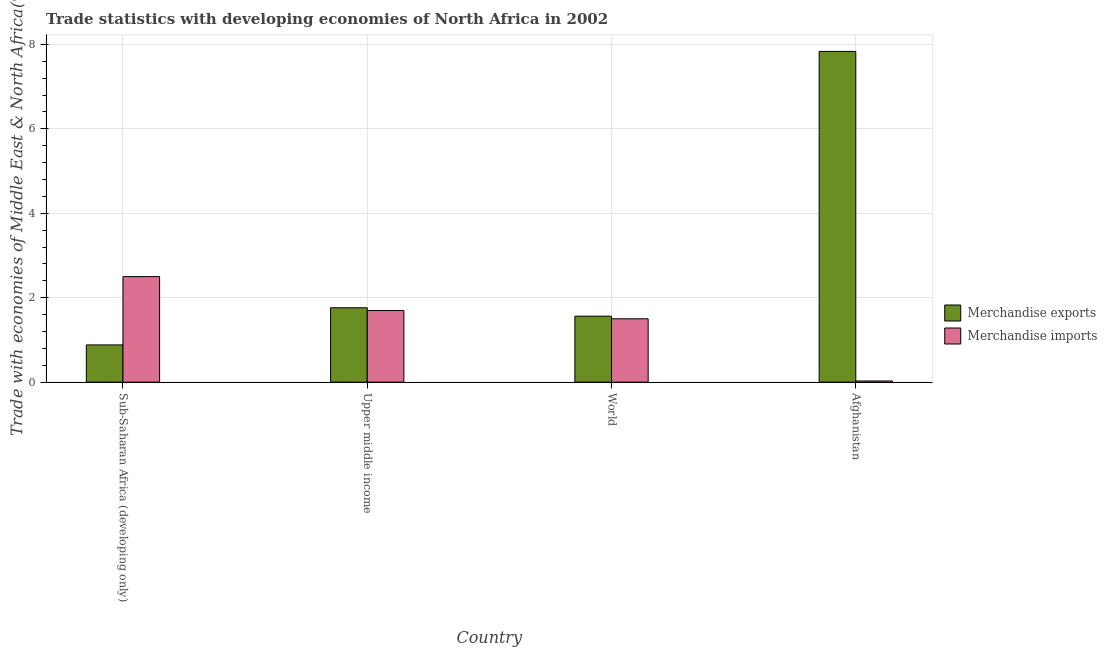How many bars are there on the 4th tick from the left?
Provide a succinct answer. 2. What is the label of the 4th group of bars from the left?
Offer a terse response. Afghanistan. What is the merchandise exports in Upper middle income?
Your response must be concise. 1.76. Across all countries, what is the maximum merchandise imports?
Offer a very short reply. 2.5. Across all countries, what is the minimum merchandise imports?
Ensure brevity in your answer.  0.03. In which country was the merchandise imports maximum?
Give a very brief answer. Sub-Saharan Africa (developing only). In which country was the merchandise imports minimum?
Your answer should be compact. Afghanistan. What is the total merchandise imports in the graph?
Offer a terse response. 5.72. What is the difference between the merchandise exports in Sub-Saharan Africa (developing only) and that in Upper middle income?
Provide a succinct answer. -0.88. What is the difference between the merchandise imports in Upper middle income and the merchandise exports in World?
Provide a succinct answer. 0.13. What is the average merchandise exports per country?
Keep it short and to the point. 3.01. What is the difference between the merchandise imports and merchandise exports in Sub-Saharan Africa (developing only)?
Provide a succinct answer. 1.62. What is the ratio of the merchandise imports in Upper middle income to that in World?
Provide a short and direct response. 1.13. Is the difference between the merchandise exports in Afghanistan and Sub-Saharan Africa (developing only) greater than the difference between the merchandise imports in Afghanistan and Sub-Saharan Africa (developing only)?
Keep it short and to the point. Yes. What is the difference between the highest and the second highest merchandise exports?
Provide a succinct answer. 6.07. What is the difference between the highest and the lowest merchandise exports?
Your answer should be very brief. 6.95. What does the 1st bar from the left in Sub-Saharan Africa (developing only) represents?
Give a very brief answer. Merchandise exports. What does the 2nd bar from the right in Upper middle income represents?
Make the answer very short. Merchandise exports. Are all the bars in the graph horizontal?
Your answer should be very brief. No. How many countries are there in the graph?
Give a very brief answer. 4. What is the difference between two consecutive major ticks on the Y-axis?
Provide a succinct answer. 2. Does the graph contain grids?
Offer a terse response. Yes. How many legend labels are there?
Your answer should be very brief. 2. How are the legend labels stacked?
Provide a short and direct response. Vertical. What is the title of the graph?
Your response must be concise. Trade statistics with developing economies of North Africa in 2002. Does "Lowest 20% of population" appear as one of the legend labels in the graph?
Provide a succinct answer. No. What is the label or title of the X-axis?
Provide a succinct answer. Country. What is the label or title of the Y-axis?
Provide a succinct answer. Trade with economies of Middle East & North Africa(%). What is the Trade with economies of Middle East & North Africa(%) in Merchandise exports in Sub-Saharan Africa (developing only)?
Your response must be concise. 0.88. What is the Trade with economies of Middle East & North Africa(%) of Merchandise imports in Sub-Saharan Africa (developing only)?
Offer a terse response. 2.5. What is the Trade with economies of Middle East & North Africa(%) in Merchandise exports in Upper middle income?
Your answer should be compact. 1.76. What is the Trade with economies of Middle East & North Africa(%) of Merchandise imports in Upper middle income?
Your answer should be compact. 1.7. What is the Trade with economies of Middle East & North Africa(%) of Merchandise exports in World?
Your answer should be compact. 1.56. What is the Trade with economies of Middle East & North Africa(%) in Merchandise imports in World?
Offer a terse response. 1.5. What is the Trade with economies of Middle East & North Africa(%) of Merchandise exports in Afghanistan?
Make the answer very short. 7.83. What is the Trade with economies of Middle East & North Africa(%) in Merchandise imports in Afghanistan?
Offer a very short reply. 0.03. Across all countries, what is the maximum Trade with economies of Middle East & North Africa(%) of Merchandise exports?
Offer a terse response. 7.83. Across all countries, what is the maximum Trade with economies of Middle East & North Africa(%) in Merchandise imports?
Provide a succinct answer. 2.5. Across all countries, what is the minimum Trade with economies of Middle East & North Africa(%) in Merchandise exports?
Give a very brief answer. 0.88. Across all countries, what is the minimum Trade with economies of Middle East & North Africa(%) in Merchandise imports?
Keep it short and to the point. 0.03. What is the total Trade with economies of Middle East & North Africa(%) in Merchandise exports in the graph?
Your answer should be compact. 12.04. What is the total Trade with economies of Middle East & North Africa(%) of Merchandise imports in the graph?
Offer a very short reply. 5.72. What is the difference between the Trade with economies of Middle East & North Africa(%) of Merchandise exports in Sub-Saharan Africa (developing only) and that in Upper middle income?
Make the answer very short. -0.88. What is the difference between the Trade with economies of Middle East & North Africa(%) in Merchandise imports in Sub-Saharan Africa (developing only) and that in Upper middle income?
Your answer should be compact. 0.8. What is the difference between the Trade with economies of Middle East & North Africa(%) of Merchandise exports in Sub-Saharan Africa (developing only) and that in World?
Your answer should be compact. -0.68. What is the difference between the Trade with economies of Middle East & North Africa(%) of Merchandise exports in Sub-Saharan Africa (developing only) and that in Afghanistan?
Offer a very short reply. -6.95. What is the difference between the Trade with economies of Middle East & North Africa(%) in Merchandise imports in Sub-Saharan Africa (developing only) and that in Afghanistan?
Offer a very short reply. 2.47. What is the difference between the Trade with economies of Middle East & North Africa(%) of Merchandise exports in Upper middle income and that in World?
Keep it short and to the point. 0.2. What is the difference between the Trade with economies of Middle East & North Africa(%) in Merchandise imports in Upper middle income and that in World?
Provide a succinct answer. 0.2. What is the difference between the Trade with economies of Middle East & North Africa(%) of Merchandise exports in Upper middle income and that in Afghanistan?
Ensure brevity in your answer.  -6.07. What is the difference between the Trade with economies of Middle East & North Africa(%) in Merchandise imports in Upper middle income and that in Afghanistan?
Your answer should be compact. 1.67. What is the difference between the Trade with economies of Middle East & North Africa(%) of Merchandise exports in World and that in Afghanistan?
Provide a succinct answer. -6.27. What is the difference between the Trade with economies of Middle East & North Africa(%) of Merchandise imports in World and that in Afghanistan?
Provide a succinct answer. 1.47. What is the difference between the Trade with economies of Middle East & North Africa(%) in Merchandise exports in Sub-Saharan Africa (developing only) and the Trade with economies of Middle East & North Africa(%) in Merchandise imports in Upper middle income?
Your answer should be compact. -0.81. What is the difference between the Trade with economies of Middle East & North Africa(%) of Merchandise exports in Sub-Saharan Africa (developing only) and the Trade with economies of Middle East & North Africa(%) of Merchandise imports in World?
Offer a very short reply. -0.62. What is the difference between the Trade with economies of Middle East & North Africa(%) of Merchandise exports in Sub-Saharan Africa (developing only) and the Trade with economies of Middle East & North Africa(%) of Merchandise imports in Afghanistan?
Offer a very short reply. 0.85. What is the difference between the Trade with economies of Middle East & North Africa(%) of Merchandise exports in Upper middle income and the Trade with economies of Middle East & North Africa(%) of Merchandise imports in World?
Provide a short and direct response. 0.26. What is the difference between the Trade with economies of Middle East & North Africa(%) in Merchandise exports in Upper middle income and the Trade with economies of Middle East & North Africa(%) in Merchandise imports in Afghanistan?
Give a very brief answer. 1.73. What is the difference between the Trade with economies of Middle East & North Africa(%) in Merchandise exports in World and the Trade with economies of Middle East & North Africa(%) in Merchandise imports in Afghanistan?
Provide a succinct answer. 1.54. What is the average Trade with economies of Middle East & North Africa(%) in Merchandise exports per country?
Provide a succinct answer. 3.01. What is the average Trade with economies of Middle East & North Africa(%) in Merchandise imports per country?
Keep it short and to the point. 1.43. What is the difference between the Trade with economies of Middle East & North Africa(%) in Merchandise exports and Trade with economies of Middle East & North Africa(%) in Merchandise imports in Sub-Saharan Africa (developing only)?
Make the answer very short. -1.62. What is the difference between the Trade with economies of Middle East & North Africa(%) in Merchandise exports and Trade with economies of Middle East & North Africa(%) in Merchandise imports in Upper middle income?
Ensure brevity in your answer.  0.07. What is the difference between the Trade with economies of Middle East & North Africa(%) of Merchandise exports and Trade with economies of Middle East & North Africa(%) of Merchandise imports in World?
Offer a terse response. 0.06. What is the difference between the Trade with economies of Middle East & North Africa(%) of Merchandise exports and Trade with economies of Middle East & North Africa(%) of Merchandise imports in Afghanistan?
Provide a succinct answer. 7.81. What is the ratio of the Trade with economies of Middle East & North Africa(%) in Merchandise exports in Sub-Saharan Africa (developing only) to that in Upper middle income?
Make the answer very short. 0.5. What is the ratio of the Trade with economies of Middle East & North Africa(%) in Merchandise imports in Sub-Saharan Africa (developing only) to that in Upper middle income?
Provide a short and direct response. 1.47. What is the ratio of the Trade with economies of Middle East & North Africa(%) in Merchandise exports in Sub-Saharan Africa (developing only) to that in World?
Keep it short and to the point. 0.56. What is the ratio of the Trade with economies of Middle East & North Africa(%) of Merchandise imports in Sub-Saharan Africa (developing only) to that in World?
Your answer should be compact. 1.67. What is the ratio of the Trade with economies of Middle East & North Africa(%) of Merchandise exports in Sub-Saharan Africa (developing only) to that in Afghanistan?
Offer a very short reply. 0.11. What is the ratio of the Trade with economies of Middle East & North Africa(%) of Merchandise imports in Sub-Saharan Africa (developing only) to that in Afghanistan?
Provide a short and direct response. 90.5. What is the ratio of the Trade with economies of Middle East & North Africa(%) of Merchandise exports in Upper middle income to that in World?
Ensure brevity in your answer.  1.13. What is the ratio of the Trade with economies of Middle East & North Africa(%) in Merchandise imports in Upper middle income to that in World?
Provide a succinct answer. 1.13. What is the ratio of the Trade with economies of Middle East & North Africa(%) of Merchandise exports in Upper middle income to that in Afghanistan?
Provide a short and direct response. 0.22. What is the ratio of the Trade with economies of Middle East & North Africa(%) of Merchandise imports in Upper middle income to that in Afghanistan?
Keep it short and to the point. 61.41. What is the ratio of the Trade with economies of Middle East & North Africa(%) in Merchandise exports in World to that in Afghanistan?
Provide a succinct answer. 0.2. What is the ratio of the Trade with economies of Middle East & North Africa(%) in Merchandise imports in World to that in Afghanistan?
Your answer should be compact. 54.35. What is the difference between the highest and the second highest Trade with economies of Middle East & North Africa(%) in Merchandise exports?
Give a very brief answer. 6.07. What is the difference between the highest and the second highest Trade with economies of Middle East & North Africa(%) of Merchandise imports?
Make the answer very short. 0.8. What is the difference between the highest and the lowest Trade with economies of Middle East & North Africa(%) in Merchandise exports?
Ensure brevity in your answer.  6.95. What is the difference between the highest and the lowest Trade with economies of Middle East & North Africa(%) of Merchandise imports?
Your answer should be compact. 2.47. 